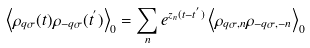Convert formula to latex. <formula><loc_0><loc_0><loc_500><loc_500>\left < \rho _ { { q } \sigma } ( t ) \rho _ { - { q } \sigma } ( t ^ { ^ { \prime } } ) \right > _ { 0 } = \sum _ { n } e ^ { z _ { n } ( t - t ^ { ^ { \prime } } ) } \left < \rho _ { { q } \sigma , n } \rho _ { - { q } \sigma , - n } \right > _ { 0 }</formula> 